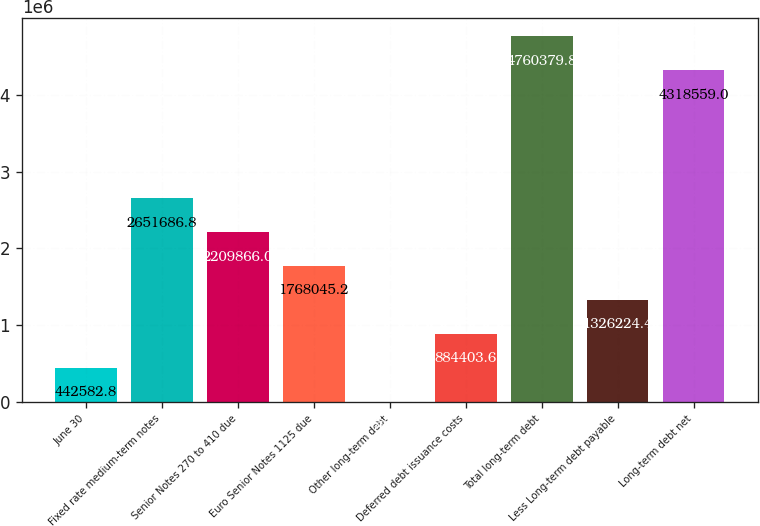Convert chart to OTSL. <chart><loc_0><loc_0><loc_500><loc_500><bar_chart><fcel>June 30<fcel>Fixed rate medium-term notes<fcel>Senior Notes 270 to 410 due<fcel>Euro Senior Notes 1125 due<fcel>Other long-term debt<fcel>Deferred debt issuance costs<fcel>Total long-term debt<fcel>Less Long-term debt payable<fcel>Long-term debt net<nl><fcel>442583<fcel>2.65169e+06<fcel>2.20987e+06<fcel>1.76805e+06<fcel>762<fcel>884404<fcel>4.76038e+06<fcel>1.32622e+06<fcel>4.31856e+06<nl></chart> 